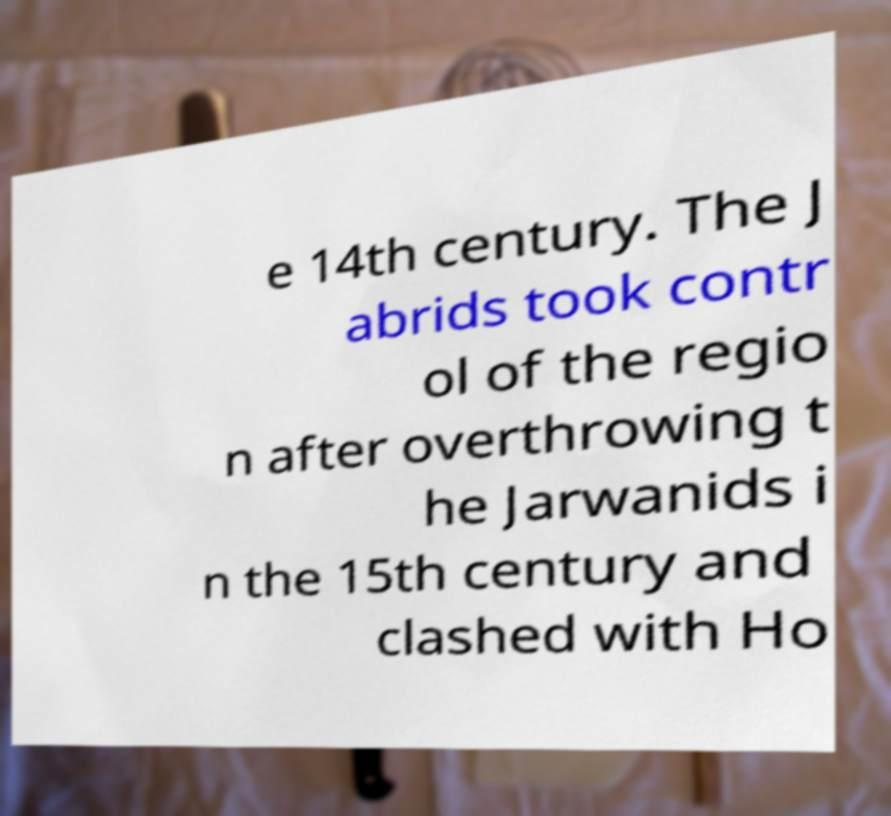There's text embedded in this image that I need extracted. Can you transcribe it verbatim? e 14th century. The J abrids took contr ol of the regio n after overthrowing t he Jarwanids i n the 15th century and clashed with Ho 